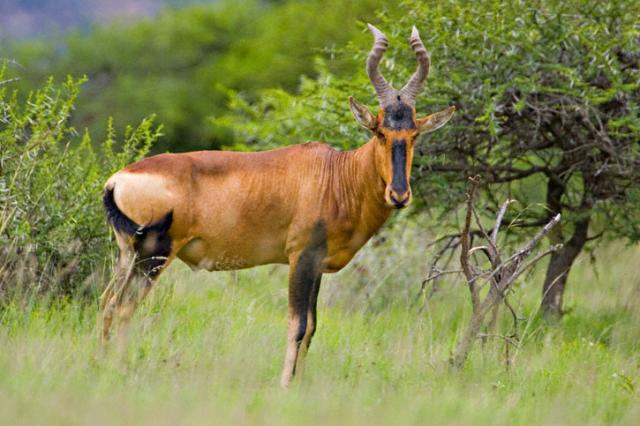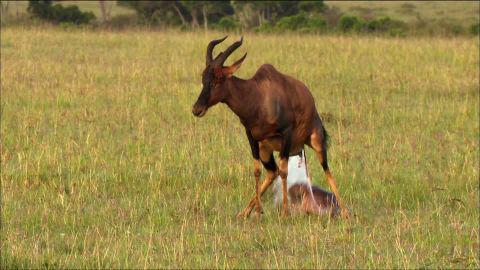The first image is the image on the left, the second image is the image on the right. Evaluate the accuracy of this statement regarding the images: "A total of three horned animals are shown in grassy areas.". Is it true? Answer yes or no. No. 